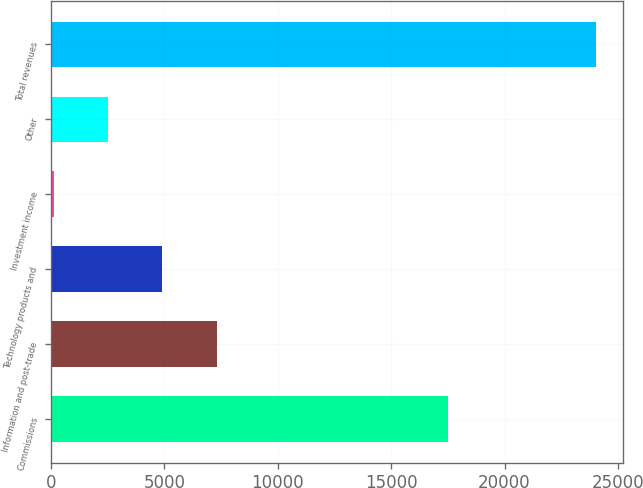Convert chart to OTSL. <chart><loc_0><loc_0><loc_500><loc_500><bar_chart><fcel>Commissions<fcel>Information and post-trade<fcel>Technology products and<fcel>Investment income<fcel>Other<fcel>Total revenues<nl><fcel>17486<fcel>7298.4<fcel>4906.6<fcel>123<fcel>2514.8<fcel>24041<nl></chart> 